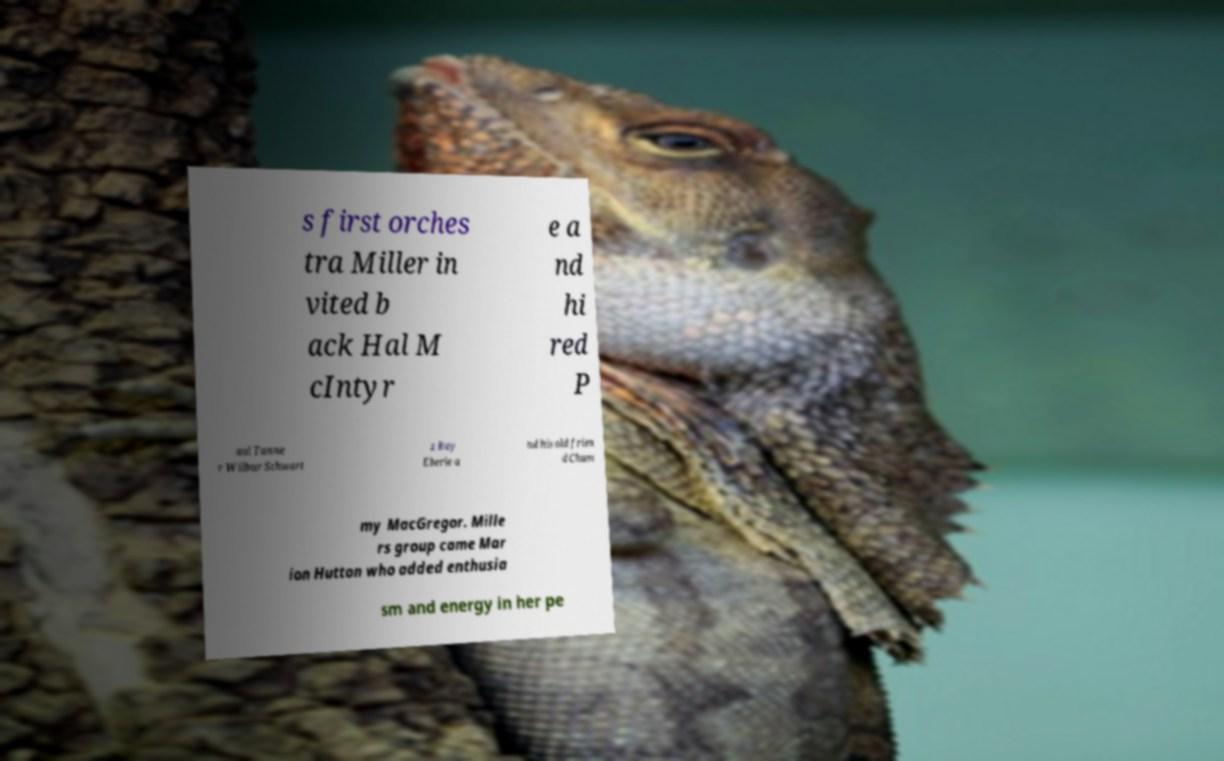Can you accurately transcribe the text from the provided image for me? s first orches tra Miller in vited b ack Hal M cIntyr e a nd hi red P aul Tanne r Wilbur Schwart z Ray Eberle a nd his old frien d Chum my MacGregor. Mille rs group came Mar ion Hutton who added enthusia sm and energy in her pe 